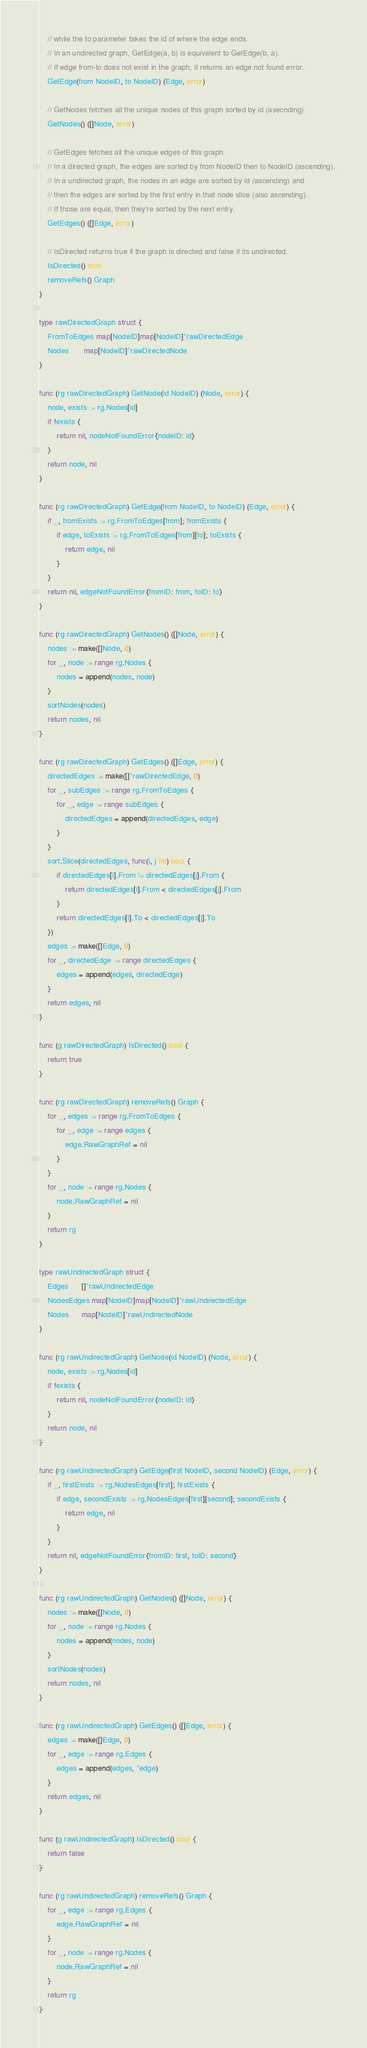Convert code to text. <code><loc_0><loc_0><loc_500><loc_500><_Go_>	// while the to parameter takes the id of where the edge ends.
	// In an undirected graph, GetEdge(a, b) is equivalent to GetEdge(b, a).
	// If edge from-to does not exist in the graph, it returns an edge not found error.
	GetEdge(from NodeID, to NodeID) (Edge, error)

	// GetNodes fetches all the unique nodes of this graph sorted by id (asecnding).
	GetNodes() ([]Node, error)

	// GetEdges fetches all the unique edges of this graph.
	// In a directed graph, the edges are sorted by from NodeID then to NodeID (ascending).
	// In a undirected graph, the nodes in an edge are sorted by id (ascending) and
	// then the edges are sorted by the first entry in that node slice (also ascending).
	// If those are equal, then they're sorted by the next entry.
	GetEdges() ([]Edge, error)

	// IsDirected returns true if the graph is directed and false if its undirected.
	IsDirected() bool
	removeRefs() Graph
}

type rawDirectedGraph struct {
	FromToEdges map[NodeID]map[NodeID]*rawDirectedEdge
	Nodes       map[NodeID]*rawDirectedNode
}

func (rg rawDirectedGraph) GetNode(id NodeID) (Node, error) {
	node, exists := rg.Nodes[id]
	if !exists {
		return nil, nodeNotFoundError{nodeID: id}
	}
	return node, nil
}

func (rg rawDirectedGraph) GetEdge(from NodeID, to NodeID) (Edge, error) {
	if _, fromExists := rg.FromToEdges[from]; fromExists {
		if edge, toExists := rg.FromToEdges[from][to]; toExists {
			return edge, nil
		}
	}
	return nil, edgeNotFoundError{fromID: from, toID: to}
}

func (rg rawDirectedGraph) GetNodes() ([]Node, error) {
	nodes := make([]Node, 0)
	for _, node := range rg.Nodes {
		nodes = append(nodes, node)
	}
	sortNodes(nodes)
	return nodes, nil
}

func (rg rawDirectedGraph) GetEdges() ([]Edge, error) {
	directedEdges := make([]*rawDirectedEdge, 0)
	for _, subEdges := range rg.FromToEdges {
		for _, edge := range subEdges {
			directedEdges = append(directedEdges, edge)
		}
	}
	sort.Slice(directedEdges, func(i, j int) bool {
		if directedEdges[i].From != directedEdges[j].From {
			return directedEdges[i].From < directedEdges[j].From
		}
		return directedEdges[i].To < directedEdges[j].To
	})
	edges := make([]Edge, 0)
	for _, directedEdge := range directedEdges {
		edges = append(edges, directedEdge)
	}
	return edges, nil
}

func (g rawDirectedGraph) IsDirected() bool {
	return true
}

func (rg rawDirectedGraph) removeRefs() Graph {
	for _, edges := range rg.FromToEdges {
		for _, edge := range edges {
			edge.RawGraphRef = nil
		}
	}
	for _, node := range rg.Nodes {
		node.RawGraphRef = nil
	}
	return rg
}

type rawUndirectedGraph struct {
	Edges      []*rawUndirectedEdge
	NodesEdges map[NodeID]map[NodeID]*rawUndirectedEdge
	Nodes      map[NodeID]*rawUndirectedNode
}

func (rg rawUndirectedGraph) GetNode(id NodeID) (Node, error) {
	node, exists := rg.Nodes[id]
	if !exists {
		return nil, nodeNotFoundError{nodeID: id}
	}
	return node, nil
}

func (rg rawUndirectedGraph) GetEdge(first NodeID, second NodeID) (Edge, error) {
	if _, firstExists := rg.NodesEdges[first]; firstExists {
		if edge, secondExists := rg.NodesEdges[first][second]; secondExists {
			return edge, nil
		}
	}
	return nil, edgeNotFoundError{fromID: first, toID: second}
}

func (rg rawUndirectedGraph) GetNodes() ([]Node, error) {
	nodes := make([]Node, 0)
	for _, node := range rg.Nodes {
		nodes = append(nodes, node)
	}
	sortNodes(nodes)
	return nodes, nil
}

func (rg rawUndirectedGraph) GetEdges() ([]Edge, error) {
	edges := make([]Edge, 0)
	for _, edge := range rg.Edges {
		edges = append(edges, *edge)
	}
	return edges, nil
}

func (g rawUndirectedGraph) IsDirected() bool {
	return false
}

func (rg rawUndirectedGraph) removeRefs() Graph {
	for _, edge := range rg.Edges {
		edge.RawGraphRef = nil
	}
	for _, node := range rg.Nodes {
		node.RawGraphRef = nil
	}
	return rg
}
</code> 